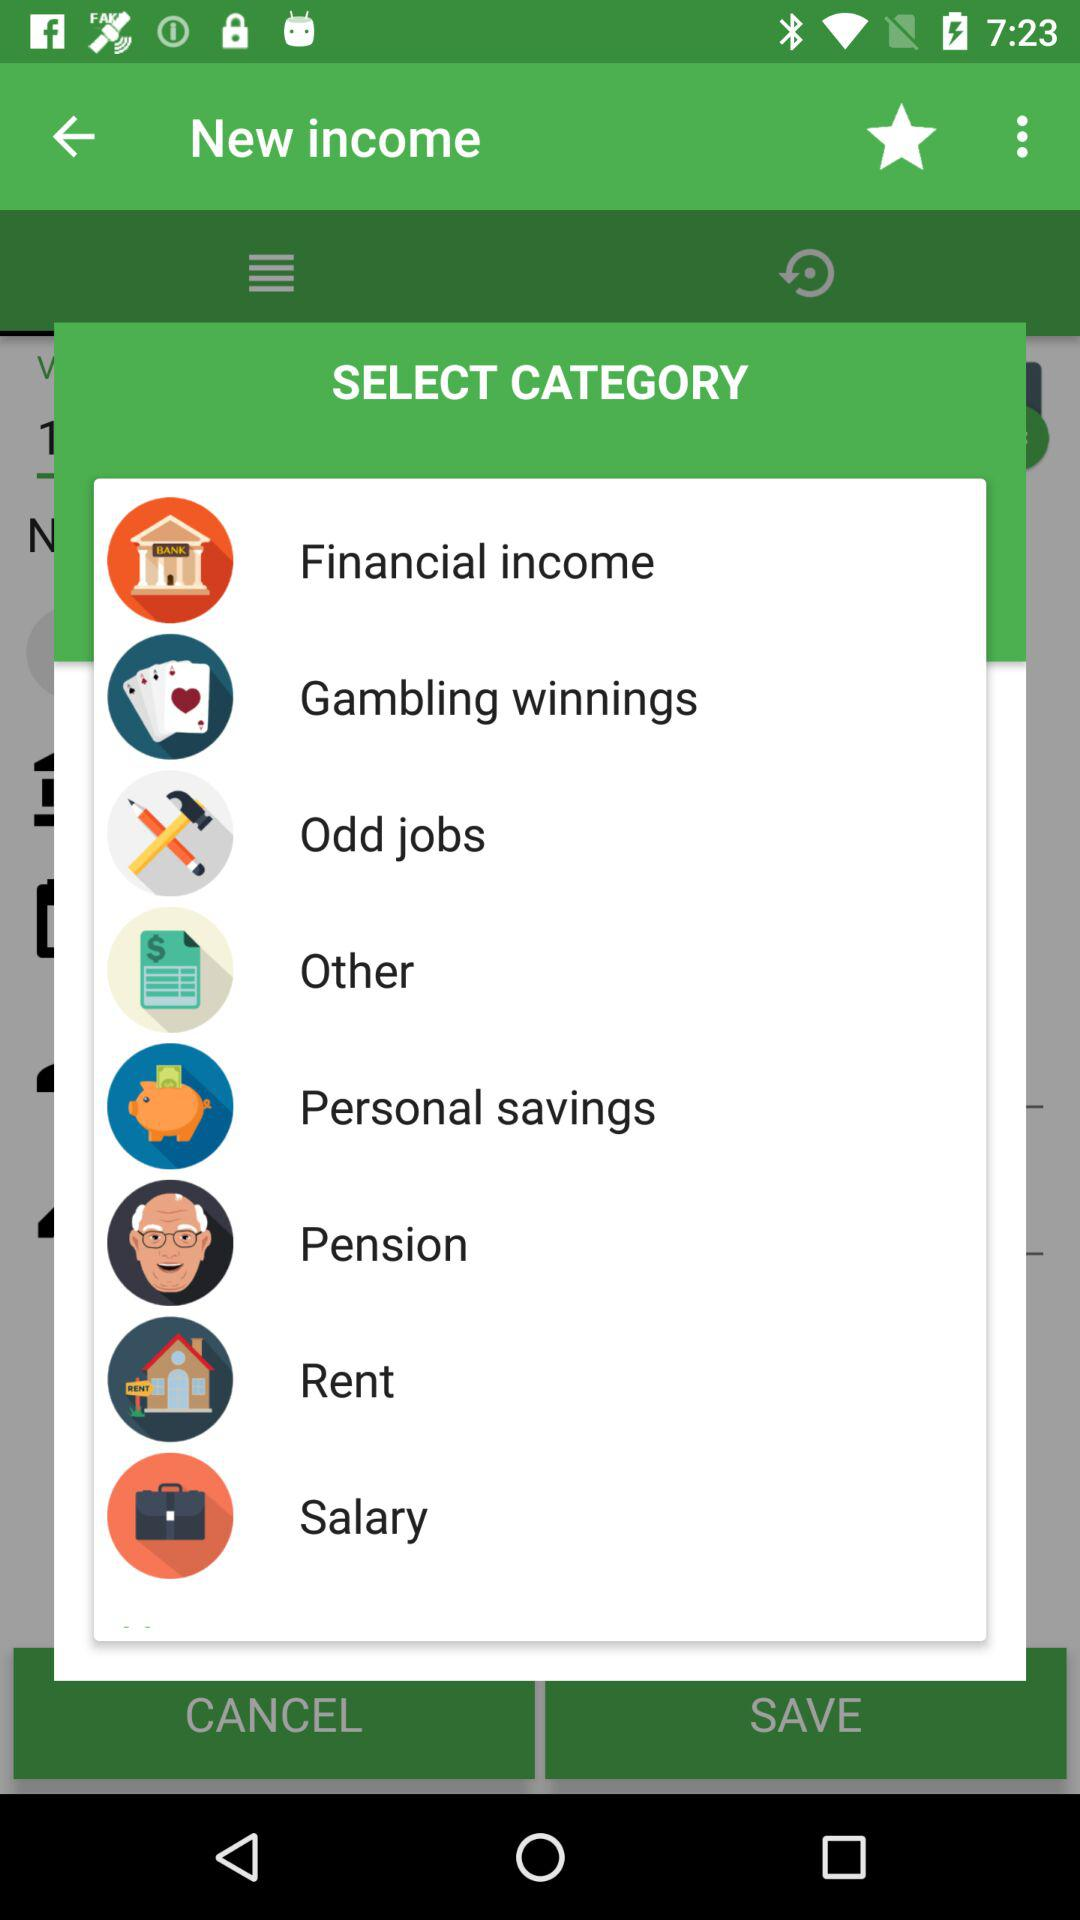How many categories are there for selecting the type of income?
Answer the question using a single word or phrase. 8 